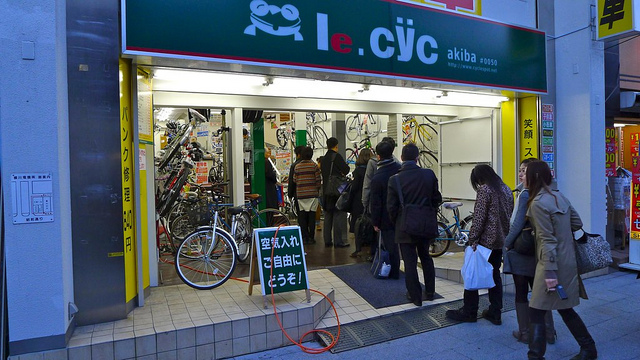<image>What is the name of this event? I don't know the name of this event. It could be 'cyc', 'lecyc', 'akiba', 'bike sale', 'bicycle sale', or 'le cyc'. What is the name of this event? It is unknown what the name of this event is. However, it could be "cyc", "lecyc", "akiba", "bike sale", "bicycle sale" or "le cyc". 